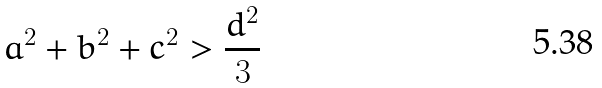Convert formula to latex. <formula><loc_0><loc_0><loc_500><loc_500>a ^ { 2 } + b ^ { 2 } + c ^ { 2 } > \frac { d ^ { 2 } } { 3 }</formula> 